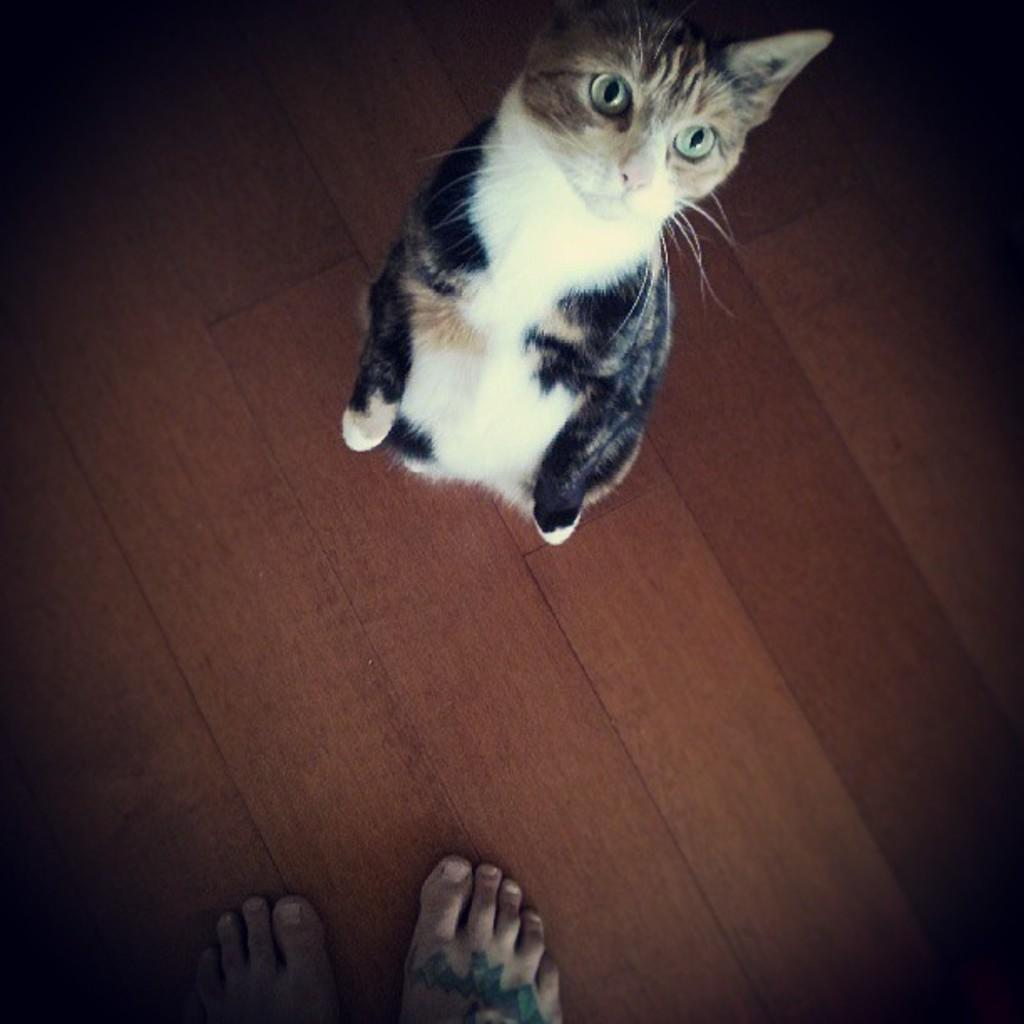What type of animal is in the image? There is a cat in the image. Where is the cat located in the image? The cat is on the floor. What colors can be seen on the cat? The cat has white and black coloring. Are there any human body parts visible in the image? Yes, there are two human legs visible in the image. What type of bag or sack is being carried by the cat in the image? There is no bag or sack present in the image; the cat is simply on the floor with its white and black coloring. 